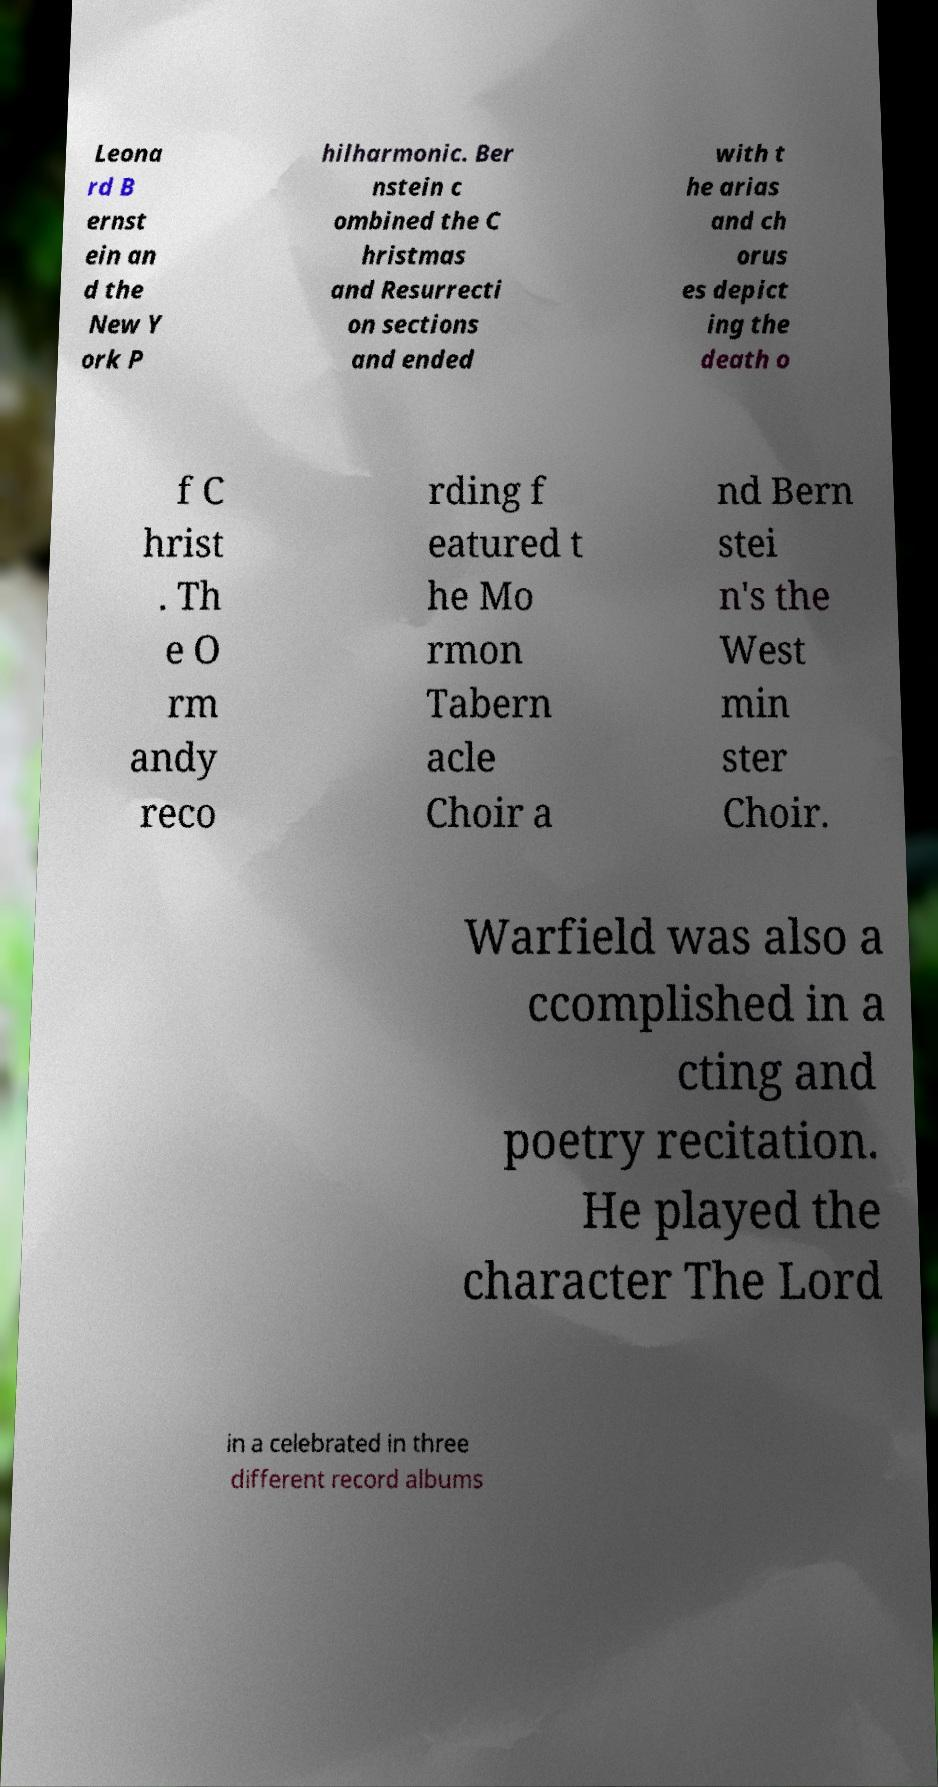Can you read and provide the text displayed in the image?This photo seems to have some interesting text. Can you extract and type it out for me? Leona rd B ernst ein an d the New Y ork P hilharmonic. Ber nstein c ombined the C hristmas and Resurrecti on sections and ended with t he arias and ch orus es depict ing the death o f C hrist . Th e O rm andy reco rding f eatured t he Mo rmon Tabern acle Choir a nd Bern stei n's the West min ster Choir. Warfield was also a ccomplished in a cting and poetry recitation. He played the character The Lord in a celebrated in three different record albums 